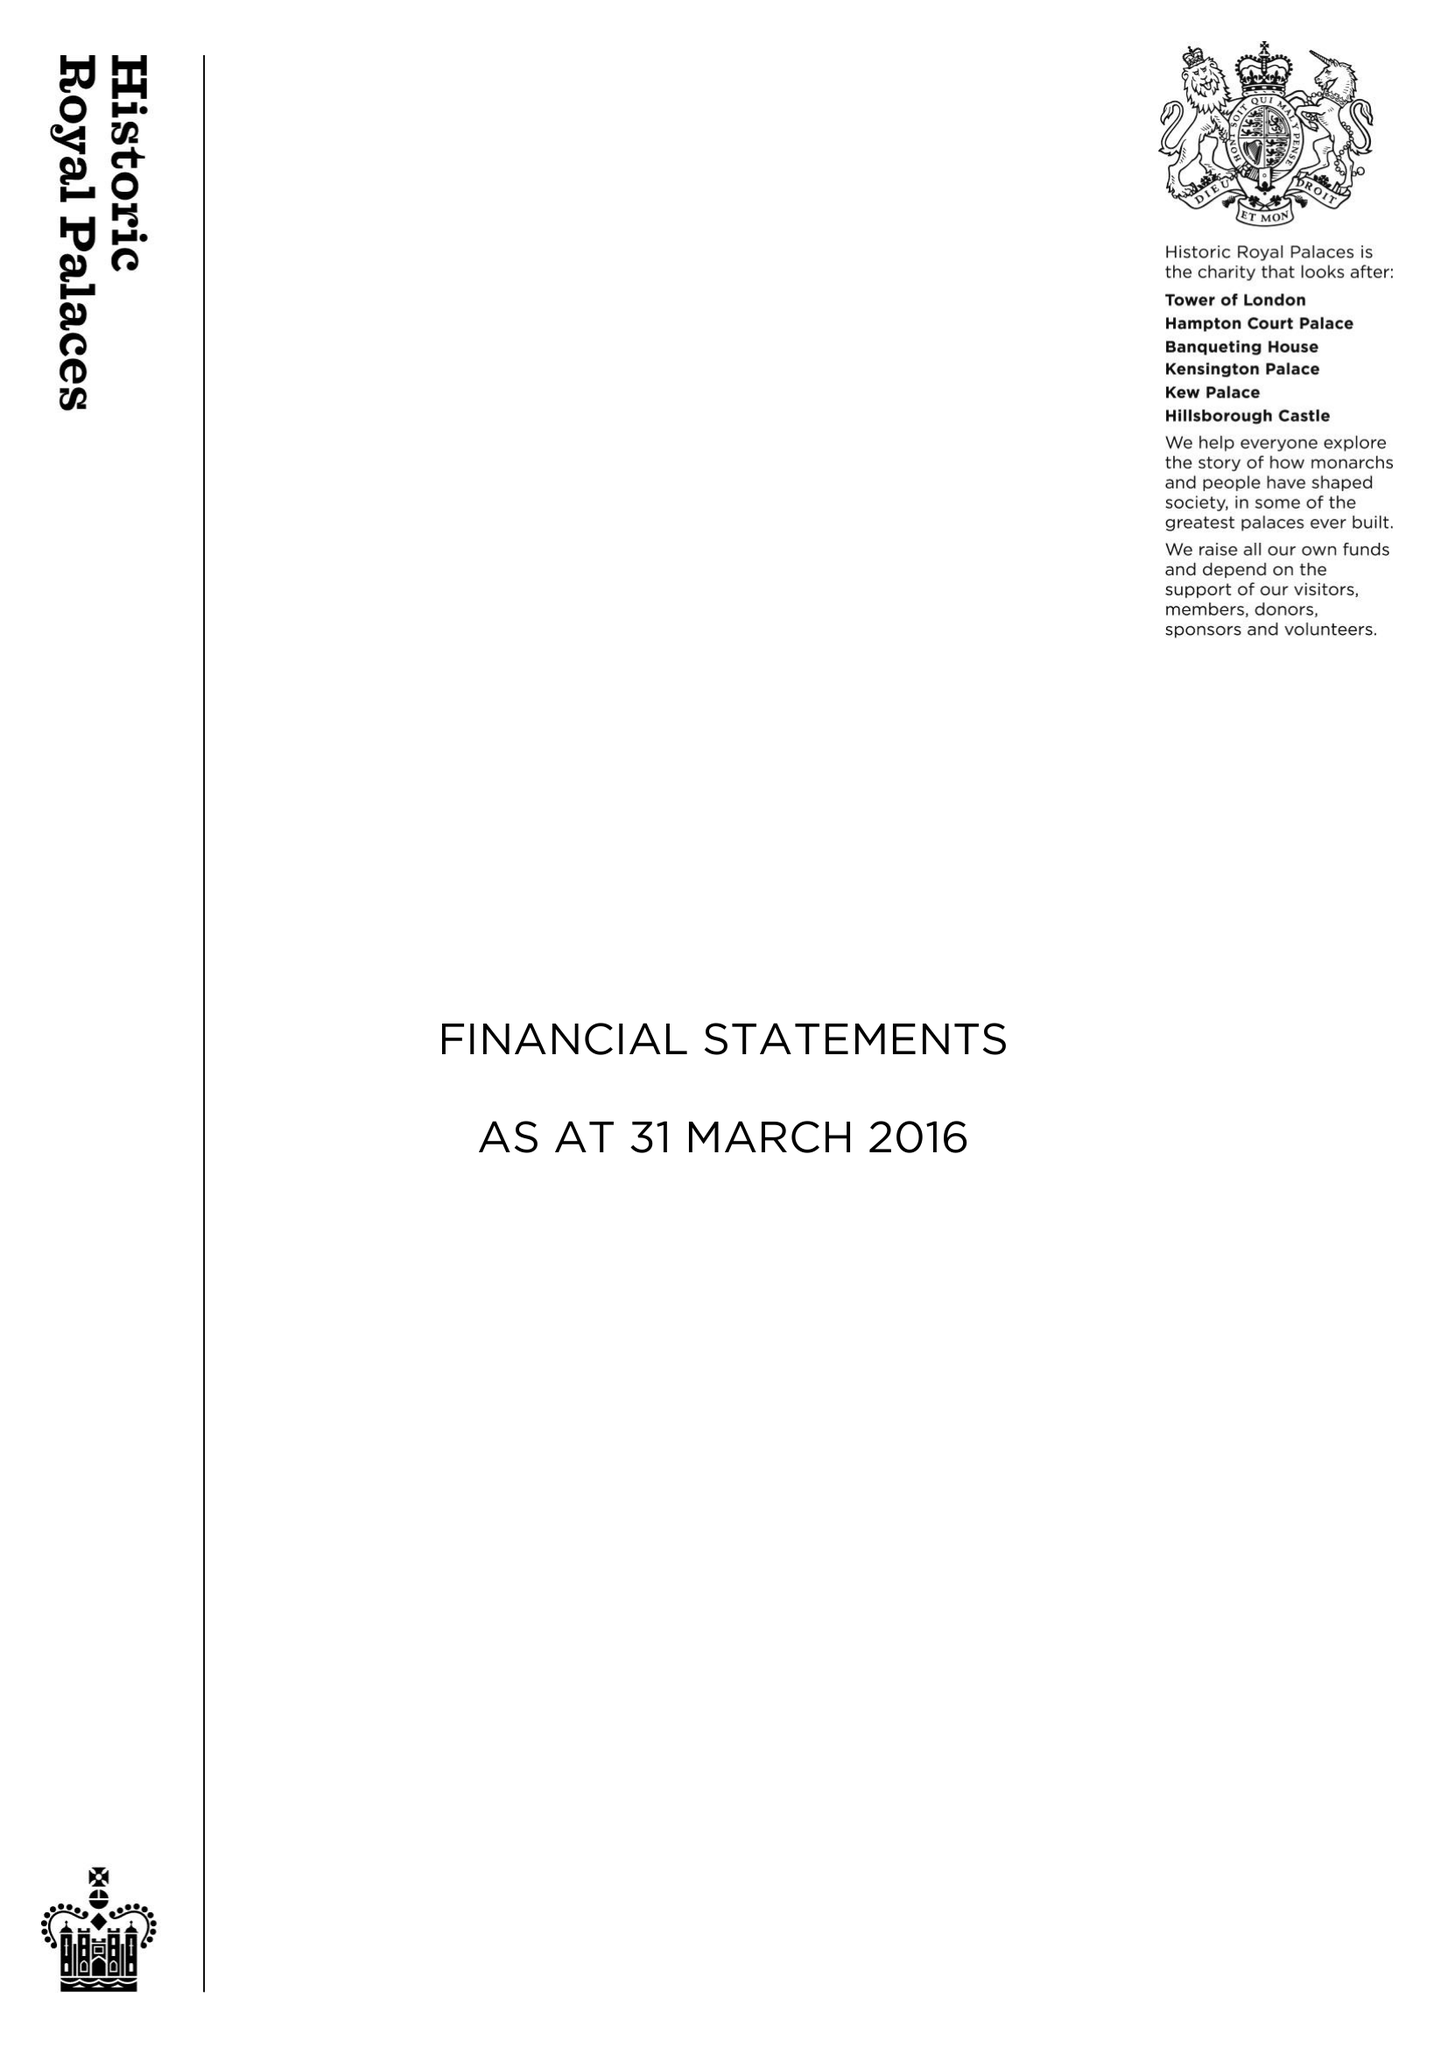What is the value for the address__street_line?
Answer the question using a single word or phrase. None 